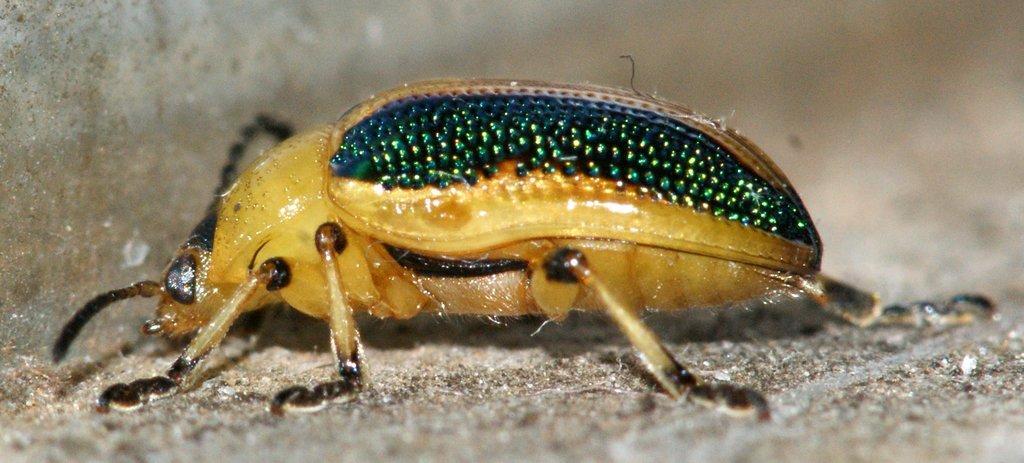How would you summarize this image in a sentence or two? This image consists of an insect. At the bottom, there is a ground. On the left, it looks like a wall. The background is blurred. 